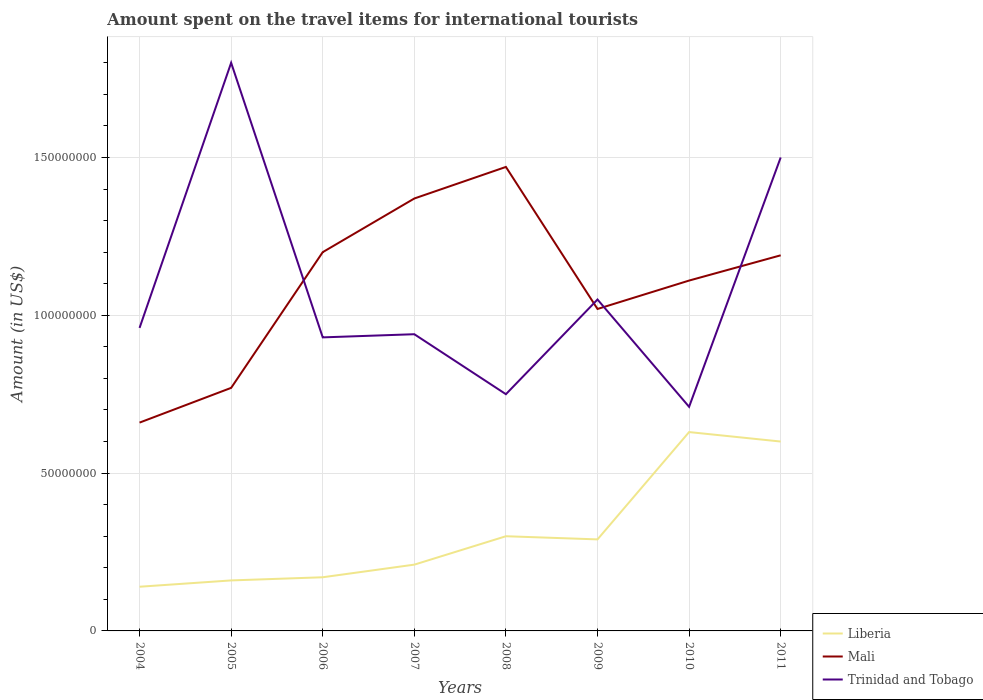How many different coloured lines are there?
Provide a short and direct response. 3. Across all years, what is the maximum amount spent on the travel items for international tourists in Mali?
Your answer should be compact. 6.60e+07. In which year was the amount spent on the travel items for international tourists in Mali maximum?
Offer a terse response. 2004. What is the total amount spent on the travel items for international tourists in Trinidad and Tobago in the graph?
Your answer should be very brief. 2.10e+07. What is the difference between the highest and the second highest amount spent on the travel items for international tourists in Liberia?
Your answer should be compact. 4.90e+07. What is the difference between the highest and the lowest amount spent on the travel items for international tourists in Trinidad and Tobago?
Your answer should be compact. 2. Is the amount spent on the travel items for international tourists in Trinidad and Tobago strictly greater than the amount spent on the travel items for international tourists in Mali over the years?
Keep it short and to the point. No. Are the values on the major ticks of Y-axis written in scientific E-notation?
Make the answer very short. No. Does the graph contain any zero values?
Ensure brevity in your answer.  No. Does the graph contain grids?
Your response must be concise. Yes. Where does the legend appear in the graph?
Offer a terse response. Bottom right. How many legend labels are there?
Your answer should be very brief. 3. What is the title of the graph?
Keep it short and to the point. Amount spent on the travel items for international tourists. Does "World" appear as one of the legend labels in the graph?
Offer a terse response. No. What is the Amount (in US$) of Liberia in 2004?
Your answer should be compact. 1.40e+07. What is the Amount (in US$) in Mali in 2004?
Provide a short and direct response. 6.60e+07. What is the Amount (in US$) in Trinidad and Tobago in 2004?
Keep it short and to the point. 9.60e+07. What is the Amount (in US$) in Liberia in 2005?
Give a very brief answer. 1.60e+07. What is the Amount (in US$) in Mali in 2005?
Your response must be concise. 7.70e+07. What is the Amount (in US$) of Trinidad and Tobago in 2005?
Make the answer very short. 1.80e+08. What is the Amount (in US$) of Liberia in 2006?
Your answer should be very brief. 1.70e+07. What is the Amount (in US$) in Mali in 2006?
Provide a short and direct response. 1.20e+08. What is the Amount (in US$) in Trinidad and Tobago in 2006?
Your answer should be very brief. 9.30e+07. What is the Amount (in US$) in Liberia in 2007?
Make the answer very short. 2.10e+07. What is the Amount (in US$) of Mali in 2007?
Give a very brief answer. 1.37e+08. What is the Amount (in US$) in Trinidad and Tobago in 2007?
Make the answer very short. 9.40e+07. What is the Amount (in US$) of Liberia in 2008?
Provide a short and direct response. 3.00e+07. What is the Amount (in US$) of Mali in 2008?
Offer a very short reply. 1.47e+08. What is the Amount (in US$) in Trinidad and Tobago in 2008?
Your answer should be compact. 7.50e+07. What is the Amount (in US$) of Liberia in 2009?
Offer a very short reply. 2.90e+07. What is the Amount (in US$) in Mali in 2009?
Give a very brief answer. 1.02e+08. What is the Amount (in US$) of Trinidad and Tobago in 2009?
Offer a terse response. 1.05e+08. What is the Amount (in US$) of Liberia in 2010?
Your response must be concise. 6.30e+07. What is the Amount (in US$) in Mali in 2010?
Your answer should be compact. 1.11e+08. What is the Amount (in US$) of Trinidad and Tobago in 2010?
Your response must be concise. 7.10e+07. What is the Amount (in US$) of Liberia in 2011?
Make the answer very short. 6.00e+07. What is the Amount (in US$) in Mali in 2011?
Offer a very short reply. 1.19e+08. What is the Amount (in US$) of Trinidad and Tobago in 2011?
Offer a terse response. 1.50e+08. Across all years, what is the maximum Amount (in US$) in Liberia?
Provide a short and direct response. 6.30e+07. Across all years, what is the maximum Amount (in US$) of Mali?
Ensure brevity in your answer.  1.47e+08. Across all years, what is the maximum Amount (in US$) in Trinidad and Tobago?
Ensure brevity in your answer.  1.80e+08. Across all years, what is the minimum Amount (in US$) of Liberia?
Offer a terse response. 1.40e+07. Across all years, what is the minimum Amount (in US$) of Mali?
Keep it short and to the point. 6.60e+07. Across all years, what is the minimum Amount (in US$) of Trinidad and Tobago?
Your answer should be compact. 7.10e+07. What is the total Amount (in US$) in Liberia in the graph?
Your answer should be compact. 2.50e+08. What is the total Amount (in US$) of Mali in the graph?
Your answer should be very brief. 8.79e+08. What is the total Amount (in US$) of Trinidad and Tobago in the graph?
Your answer should be compact. 8.64e+08. What is the difference between the Amount (in US$) in Liberia in 2004 and that in 2005?
Your answer should be compact. -2.00e+06. What is the difference between the Amount (in US$) of Mali in 2004 and that in 2005?
Give a very brief answer. -1.10e+07. What is the difference between the Amount (in US$) in Trinidad and Tobago in 2004 and that in 2005?
Provide a succinct answer. -8.40e+07. What is the difference between the Amount (in US$) in Mali in 2004 and that in 2006?
Your response must be concise. -5.40e+07. What is the difference between the Amount (in US$) in Liberia in 2004 and that in 2007?
Provide a short and direct response. -7.00e+06. What is the difference between the Amount (in US$) of Mali in 2004 and that in 2007?
Provide a short and direct response. -7.10e+07. What is the difference between the Amount (in US$) of Trinidad and Tobago in 2004 and that in 2007?
Keep it short and to the point. 2.00e+06. What is the difference between the Amount (in US$) in Liberia in 2004 and that in 2008?
Offer a very short reply. -1.60e+07. What is the difference between the Amount (in US$) of Mali in 2004 and that in 2008?
Give a very brief answer. -8.10e+07. What is the difference between the Amount (in US$) in Trinidad and Tobago in 2004 and that in 2008?
Your response must be concise. 2.10e+07. What is the difference between the Amount (in US$) of Liberia in 2004 and that in 2009?
Provide a short and direct response. -1.50e+07. What is the difference between the Amount (in US$) in Mali in 2004 and that in 2009?
Your answer should be compact. -3.60e+07. What is the difference between the Amount (in US$) in Trinidad and Tobago in 2004 and that in 2009?
Your response must be concise. -9.00e+06. What is the difference between the Amount (in US$) in Liberia in 2004 and that in 2010?
Give a very brief answer. -4.90e+07. What is the difference between the Amount (in US$) of Mali in 2004 and that in 2010?
Provide a short and direct response. -4.50e+07. What is the difference between the Amount (in US$) of Trinidad and Tobago in 2004 and that in 2010?
Make the answer very short. 2.50e+07. What is the difference between the Amount (in US$) of Liberia in 2004 and that in 2011?
Your answer should be very brief. -4.60e+07. What is the difference between the Amount (in US$) of Mali in 2004 and that in 2011?
Provide a short and direct response. -5.30e+07. What is the difference between the Amount (in US$) of Trinidad and Tobago in 2004 and that in 2011?
Provide a short and direct response. -5.40e+07. What is the difference between the Amount (in US$) of Mali in 2005 and that in 2006?
Ensure brevity in your answer.  -4.30e+07. What is the difference between the Amount (in US$) in Trinidad and Tobago in 2005 and that in 2006?
Provide a succinct answer. 8.70e+07. What is the difference between the Amount (in US$) in Liberia in 2005 and that in 2007?
Your answer should be compact. -5.00e+06. What is the difference between the Amount (in US$) in Mali in 2005 and that in 2007?
Give a very brief answer. -6.00e+07. What is the difference between the Amount (in US$) in Trinidad and Tobago in 2005 and that in 2007?
Give a very brief answer. 8.60e+07. What is the difference between the Amount (in US$) of Liberia in 2005 and that in 2008?
Your response must be concise. -1.40e+07. What is the difference between the Amount (in US$) in Mali in 2005 and that in 2008?
Keep it short and to the point. -7.00e+07. What is the difference between the Amount (in US$) in Trinidad and Tobago in 2005 and that in 2008?
Make the answer very short. 1.05e+08. What is the difference between the Amount (in US$) in Liberia in 2005 and that in 2009?
Provide a short and direct response. -1.30e+07. What is the difference between the Amount (in US$) in Mali in 2005 and that in 2009?
Provide a short and direct response. -2.50e+07. What is the difference between the Amount (in US$) of Trinidad and Tobago in 2005 and that in 2009?
Keep it short and to the point. 7.50e+07. What is the difference between the Amount (in US$) in Liberia in 2005 and that in 2010?
Your response must be concise. -4.70e+07. What is the difference between the Amount (in US$) of Mali in 2005 and that in 2010?
Provide a succinct answer. -3.40e+07. What is the difference between the Amount (in US$) of Trinidad and Tobago in 2005 and that in 2010?
Your answer should be compact. 1.09e+08. What is the difference between the Amount (in US$) of Liberia in 2005 and that in 2011?
Your response must be concise. -4.40e+07. What is the difference between the Amount (in US$) of Mali in 2005 and that in 2011?
Your answer should be compact. -4.20e+07. What is the difference between the Amount (in US$) of Trinidad and Tobago in 2005 and that in 2011?
Provide a succinct answer. 3.00e+07. What is the difference between the Amount (in US$) in Liberia in 2006 and that in 2007?
Keep it short and to the point. -4.00e+06. What is the difference between the Amount (in US$) of Mali in 2006 and that in 2007?
Offer a very short reply. -1.70e+07. What is the difference between the Amount (in US$) in Trinidad and Tobago in 2006 and that in 2007?
Offer a terse response. -1.00e+06. What is the difference between the Amount (in US$) in Liberia in 2006 and that in 2008?
Your answer should be compact. -1.30e+07. What is the difference between the Amount (in US$) of Mali in 2006 and that in 2008?
Make the answer very short. -2.70e+07. What is the difference between the Amount (in US$) in Trinidad and Tobago in 2006 and that in 2008?
Offer a terse response. 1.80e+07. What is the difference between the Amount (in US$) of Liberia in 2006 and that in 2009?
Offer a terse response. -1.20e+07. What is the difference between the Amount (in US$) in Mali in 2006 and that in 2009?
Provide a succinct answer. 1.80e+07. What is the difference between the Amount (in US$) of Trinidad and Tobago in 2006 and that in 2009?
Offer a terse response. -1.20e+07. What is the difference between the Amount (in US$) in Liberia in 2006 and that in 2010?
Ensure brevity in your answer.  -4.60e+07. What is the difference between the Amount (in US$) in Mali in 2006 and that in 2010?
Ensure brevity in your answer.  9.00e+06. What is the difference between the Amount (in US$) in Trinidad and Tobago in 2006 and that in 2010?
Keep it short and to the point. 2.20e+07. What is the difference between the Amount (in US$) in Liberia in 2006 and that in 2011?
Offer a terse response. -4.30e+07. What is the difference between the Amount (in US$) in Trinidad and Tobago in 2006 and that in 2011?
Offer a very short reply. -5.70e+07. What is the difference between the Amount (in US$) of Liberia in 2007 and that in 2008?
Provide a succinct answer. -9.00e+06. What is the difference between the Amount (in US$) of Mali in 2007 and that in 2008?
Your answer should be very brief. -1.00e+07. What is the difference between the Amount (in US$) of Trinidad and Tobago in 2007 and that in 2008?
Give a very brief answer. 1.90e+07. What is the difference between the Amount (in US$) of Liberia in 2007 and that in 2009?
Offer a very short reply. -8.00e+06. What is the difference between the Amount (in US$) in Mali in 2007 and that in 2009?
Your answer should be very brief. 3.50e+07. What is the difference between the Amount (in US$) of Trinidad and Tobago in 2007 and that in 2009?
Your response must be concise. -1.10e+07. What is the difference between the Amount (in US$) of Liberia in 2007 and that in 2010?
Make the answer very short. -4.20e+07. What is the difference between the Amount (in US$) of Mali in 2007 and that in 2010?
Offer a very short reply. 2.60e+07. What is the difference between the Amount (in US$) in Trinidad and Tobago in 2007 and that in 2010?
Offer a very short reply. 2.30e+07. What is the difference between the Amount (in US$) in Liberia in 2007 and that in 2011?
Ensure brevity in your answer.  -3.90e+07. What is the difference between the Amount (in US$) of Mali in 2007 and that in 2011?
Ensure brevity in your answer.  1.80e+07. What is the difference between the Amount (in US$) of Trinidad and Tobago in 2007 and that in 2011?
Provide a short and direct response. -5.60e+07. What is the difference between the Amount (in US$) in Mali in 2008 and that in 2009?
Your answer should be very brief. 4.50e+07. What is the difference between the Amount (in US$) in Trinidad and Tobago in 2008 and that in 2009?
Provide a succinct answer. -3.00e+07. What is the difference between the Amount (in US$) of Liberia in 2008 and that in 2010?
Keep it short and to the point. -3.30e+07. What is the difference between the Amount (in US$) of Mali in 2008 and that in 2010?
Keep it short and to the point. 3.60e+07. What is the difference between the Amount (in US$) of Liberia in 2008 and that in 2011?
Keep it short and to the point. -3.00e+07. What is the difference between the Amount (in US$) of Mali in 2008 and that in 2011?
Give a very brief answer. 2.80e+07. What is the difference between the Amount (in US$) in Trinidad and Tobago in 2008 and that in 2011?
Offer a terse response. -7.50e+07. What is the difference between the Amount (in US$) in Liberia in 2009 and that in 2010?
Keep it short and to the point. -3.40e+07. What is the difference between the Amount (in US$) of Mali in 2009 and that in 2010?
Offer a very short reply. -9.00e+06. What is the difference between the Amount (in US$) in Trinidad and Tobago in 2009 and that in 2010?
Provide a succinct answer. 3.40e+07. What is the difference between the Amount (in US$) of Liberia in 2009 and that in 2011?
Your answer should be very brief. -3.10e+07. What is the difference between the Amount (in US$) of Mali in 2009 and that in 2011?
Provide a short and direct response. -1.70e+07. What is the difference between the Amount (in US$) in Trinidad and Tobago in 2009 and that in 2011?
Offer a very short reply. -4.50e+07. What is the difference between the Amount (in US$) of Liberia in 2010 and that in 2011?
Provide a short and direct response. 3.00e+06. What is the difference between the Amount (in US$) in Mali in 2010 and that in 2011?
Your answer should be compact. -8.00e+06. What is the difference between the Amount (in US$) in Trinidad and Tobago in 2010 and that in 2011?
Offer a very short reply. -7.90e+07. What is the difference between the Amount (in US$) of Liberia in 2004 and the Amount (in US$) of Mali in 2005?
Make the answer very short. -6.30e+07. What is the difference between the Amount (in US$) of Liberia in 2004 and the Amount (in US$) of Trinidad and Tobago in 2005?
Offer a very short reply. -1.66e+08. What is the difference between the Amount (in US$) in Mali in 2004 and the Amount (in US$) in Trinidad and Tobago in 2005?
Ensure brevity in your answer.  -1.14e+08. What is the difference between the Amount (in US$) in Liberia in 2004 and the Amount (in US$) in Mali in 2006?
Ensure brevity in your answer.  -1.06e+08. What is the difference between the Amount (in US$) of Liberia in 2004 and the Amount (in US$) of Trinidad and Tobago in 2006?
Your answer should be compact. -7.90e+07. What is the difference between the Amount (in US$) of Mali in 2004 and the Amount (in US$) of Trinidad and Tobago in 2006?
Your response must be concise. -2.70e+07. What is the difference between the Amount (in US$) of Liberia in 2004 and the Amount (in US$) of Mali in 2007?
Your answer should be very brief. -1.23e+08. What is the difference between the Amount (in US$) in Liberia in 2004 and the Amount (in US$) in Trinidad and Tobago in 2007?
Give a very brief answer. -8.00e+07. What is the difference between the Amount (in US$) of Mali in 2004 and the Amount (in US$) of Trinidad and Tobago in 2007?
Ensure brevity in your answer.  -2.80e+07. What is the difference between the Amount (in US$) in Liberia in 2004 and the Amount (in US$) in Mali in 2008?
Keep it short and to the point. -1.33e+08. What is the difference between the Amount (in US$) of Liberia in 2004 and the Amount (in US$) of Trinidad and Tobago in 2008?
Make the answer very short. -6.10e+07. What is the difference between the Amount (in US$) of Mali in 2004 and the Amount (in US$) of Trinidad and Tobago in 2008?
Give a very brief answer. -9.00e+06. What is the difference between the Amount (in US$) in Liberia in 2004 and the Amount (in US$) in Mali in 2009?
Your response must be concise. -8.80e+07. What is the difference between the Amount (in US$) in Liberia in 2004 and the Amount (in US$) in Trinidad and Tobago in 2009?
Provide a succinct answer. -9.10e+07. What is the difference between the Amount (in US$) in Mali in 2004 and the Amount (in US$) in Trinidad and Tobago in 2009?
Your answer should be compact. -3.90e+07. What is the difference between the Amount (in US$) in Liberia in 2004 and the Amount (in US$) in Mali in 2010?
Your answer should be very brief. -9.70e+07. What is the difference between the Amount (in US$) in Liberia in 2004 and the Amount (in US$) in Trinidad and Tobago in 2010?
Provide a succinct answer. -5.70e+07. What is the difference between the Amount (in US$) in Mali in 2004 and the Amount (in US$) in Trinidad and Tobago in 2010?
Offer a terse response. -5.00e+06. What is the difference between the Amount (in US$) of Liberia in 2004 and the Amount (in US$) of Mali in 2011?
Provide a short and direct response. -1.05e+08. What is the difference between the Amount (in US$) of Liberia in 2004 and the Amount (in US$) of Trinidad and Tobago in 2011?
Give a very brief answer. -1.36e+08. What is the difference between the Amount (in US$) of Mali in 2004 and the Amount (in US$) of Trinidad and Tobago in 2011?
Your response must be concise. -8.40e+07. What is the difference between the Amount (in US$) of Liberia in 2005 and the Amount (in US$) of Mali in 2006?
Ensure brevity in your answer.  -1.04e+08. What is the difference between the Amount (in US$) of Liberia in 2005 and the Amount (in US$) of Trinidad and Tobago in 2006?
Offer a very short reply. -7.70e+07. What is the difference between the Amount (in US$) of Mali in 2005 and the Amount (in US$) of Trinidad and Tobago in 2006?
Ensure brevity in your answer.  -1.60e+07. What is the difference between the Amount (in US$) in Liberia in 2005 and the Amount (in US$) in Mali in 2007?
Your answer should be very brief. -1.21e+08. What is the difference between the Amount (in US$) in Liberia in 2005 and the Amount (in US$) in Trinidad and Tobago in 2007?
Offer a very short reply. -7.80e+07. What is the difference between the Amount (in US$) of Mali in 2005 and the Amount (in US$) of Trinidad and Tobago in 2007?
Offer a terse response. -1.70e+07. What is the difference between the Amount (in US$) of Liberia in 2005 and the Amount (in US$) of Mali in 2008?
Offer a very short reply. -1.31e+08. What is the difference between the Amount (in US$) of Liberia in 2005 and the Amount (in US$) of Trinidad and Tobago in 2008?
Provide a succinct answer. -5.90e+07. What is the difference between the Amount (in US$) in Liberia in 2005 and the Amount (in US$) in Mali in 2009?
Offer a terse response. -8.60e+07. What is the difference between the Amount (in US$) in Liberia in 2005 and the Amount (in US$) in Trinidad and Tobago in 2009?
Keep it short and to the point. -8.90e+07. What is the difference between the Amount (in US$) in Mali in 2005 and the Amount (in US$) in Trinidad and Tobago in 2009?
Provide a short and direct response. -2.80e+07. What is the difference between the Amount (in US$) of Liberia in 2005 and the Amount (in US$) of Mali in 2010?
Your answer should be compact. -9.50e+07. What is the difference between the Amount (in US$) of Liberia in 2005 and the Amount (in US$) of Trinidad and Tobago in 2010?
Provide a succinct answer. -5.50e+07. What is the difference between the Amount (in US$) of Liberia in 2005 and the Amount (in US$) of Mali in 2011?
Make the answer very short. -1.03e+08. What is the difference between the Amount (in US$) of Liberia in 2005 and the Amount (in US$) of Trinidad and Tobago in 2011?
Offer a very short reply. -1.34e+08. What is the difference between the Amount (in US$) of Mali in 2005 and the Amount (in US$) of Trinidad and Tobago in 2011?
Provide a succinct answer. -7.30e+07. What is the difference between the Amount (in US$) of Liberia in 2006 and the Amount (in US$) of Mali in 2007?
Your answer should be compact. -1.20e+08. What is the difference between the Amount (in US$) of Liberia in 2006 and the Amount (in US$) of Trinidad and Tobago in 2007?
Provide a succinct answer. -7.70e+07. What is the difference between the Amount (in US$) of Mali in 2006 and the Amount (in US$) of Trinidad and Tobago in 2007?
Keep it short and to the point. 2.60e+07. What is the difference between the Amount (in US$) in Liberia in 2006 and the Amount (in US$) in Mali in 2008?
Your response must be concise. -1.30e+08. What is the difference between the Amount (in US$) in Liberia in 2006 and the Amount (in US$) in Trinidad and Tobago in 2008?
Provide a succinct answer. -5.80e+07. What is the difference between the Amount (in US$) of Mali in 2006 and the Amount (in US$) of Trinidad and Tobago in 2008?
Your answer should be compact. 4.50e+07. What is the difference between the Amount (in US$) in Liberia in 2006 and the Amount (in US$) in Mali in 2009?
Ensure brevity in your answer.  -8.50e+07. What is the difference between the Amount (in US$) of Liberia in 2006 and the Amount (in US$) of Trinidad and Tobago in 2009?
Your answer should be compact. -8.80e+07. What is the difference between the Amount (in US$) in Mali in 2006 and the Amount (in US$) in Trinidad and Tobago in 2009?
Your answer should be compact. 1.50e+07. What is the difference between the Amount (in US$) of Liberia in 2006 and the Amount (in US$) of Mali in 2010?
Provide a short and direct response. -9.40e+07. What is the difference between the Amount (in US$) of Liberia in 2006 and the Amount (in US$) of Trinidad and Tobago in 2010?
Give a very brief answer. -5.40e+07. What is the difference between the Amount (in US$) in Mali in 2006 and the Amount (in US$) in Trinidad and Tobago in 2010?
Ensure brevity in your answer.  4.90e+07. What is the difference between the Amount (in US$) of Liberia in 2006 and the Amount (in US$) of Mali in 2011?
Offer a very short reply. -1.02e+08. What is the difference between the Amount (in US$) in Liberia in 2006 and the Amount (in US$) in Trinidad and Tobago in 2011?
Ensure brevity in your answer.  -1.33e+08. What is the difference between the Amount (in US$) in Mali in 2006 and the Amount (in US$) in Trinidad and Tobago in 2011?
Make the answer very short. -3.00e+07. What is the difference between the Amount (in US$) in Liberia in 2007 and the Amount (in US$) in Mali in 2008?
Give a very brief answer. -1.26e+08. What is the difference between the Amount (in US$) of Liberia in 2007 and the Amount (in US$) of Trinidad and Tobago in 2008?
Your answer should be compact. -5.40e+07. What is the difference between the Amount (in US$) in Mali in 2007 and the Amount (in US$) in Trinidad and Tobago in 2008?
Provide a succinct answer. 6.20e+07. What is the difference between the Amount (in US$) in Liberia in 2007 and the Amount (in US$) in Mali in 2009?
Your answer should be compact. -8.10e+07. What is the difference between the Amount (in US$) of Liberia in 2007 and the Amount (in US$) of Trinidad and Tobago in 2009?
Keep it short and to the point. -8.40e+07. What is the difference between the Amount (in US$) of Mali in 2007 and the Amount (in US$) of Trinidad and Tobago in 2009?
Offer a terse response. 3.20e+07. What is the difference between the Amount (in US$) of Liberia in 2007 and the Amount (in US$) of Mali in 2010?
Give a very brief answer. -9.00e+07. What is the difference between the Amount (in US$) of Liberia in 2007 and the Amount (in US$) of Trinidad and Tobago in 2010?
Keep it short and to the point. -5.00e+07. What is the difference between the Amount (in US$) of Mali in 2007 and the Amount (in US$) of Trinidad and Tobago in 2010?
Keep it short and to the point. 6.60e+07. What is the difference between the Amount (in US$) in Liberia in 2007 and the Amount (in US$) in Mali in 2011?
Give a very brief answer. -9.80e+07. What is the difference between the Amount (in US$) in Liberia in 2007 and the Amount (in US$) in Trinidad and Tobago in 2011?
Keep it short and to the point. -1.29e+08. What is the difference between the Amount (in US$) in Mali in 2007 and the Amount (in US$) in Trinidad and Tobago in 2011?
Ensure brevity in your answer.  -1.30e+07. What is the difference between the Amount (in US$) in Liberia in 2008 and the Amount (in US$) in Mali in 2009?
Offer a very short reply. -7.20e+07. What is the difference between the Amount (in US$) of Liberia in 2008 and the Amount (in US$) of Trinidad and Tobago in 2009?
Your response must be concise. -7.50e+07. What is the difference between the Amount (in US$) of Mali in 2008 and the Amount (in US$) of Trinidad and Tobago in 2009?
Keep it short and to the point. 4.20e+07. What is the difference between the Amount (in US$) in Liberia in 2008 and the Amount (in US$) in Mali in 2010?
Keep it short and to the point. -8.10e+07. What is the difference between the Amount (in US$) in Liberia in 2008 and the Amount (in US$) in Trinidad and Tobago in 2010?
Your response must be concise. -4.10e+07. What is the difference between the Amount (in US$) of Mali in 2008 and the Amount (in US$) of Trinidad and Tobago in 2010?
Provide a succinct answer. 7.60e+07. What is the difference between the Amount (in US$) of Liberia in 2008 and the Amount (in US$) of Mali in 2011?
Offer a terse response. -8.90e+07. What is the difference between the Amount (in US$) of Liberia in 2008 and the Amount (in US$) of Trinidad and Tobago in 2011?
Give a very brief answer. -1.20e+08. What is the difference between the Amount (in US$) in Mali in 2008 and the Amount (in US$) in Trinidad and Tobago in 2011?
Make the answer very short. -3.00e+06. What is the difference between the Amount (in US$) in Liberia in 2009 and the Amount (in US$) in Mali in 2010?
Ensure brevity in your answer.  -8.20e+07. What is the difference between the Amount (in US$) of Liberia in 2009 and the Amount (in US$) of Trinidad and Tobago in 2010?
Provide a short and direct response. -4.20e+07. What is the difference between the Amount (in US$) of Mali in 2009 and the Amount (in US$) of Trinidad and Tobago in 2010?
Your response must be concise. 3.10e+07. What is the difference between the Amount (in US$) in Liberia in 2009 and the Amount (in US$) in Mali in 2011?
Ensure brevity in your answer.  -9.00e+07. What is the difference between the Amount (in US$) of Liberia in 2009 and the Amount (in US$) of Trinidad and Tobago in 2011?
Ensure brevity in your answer.  -1.21e+08. What is the difference between the Amount (in US$) in Mali in 2009 and the Amount (in US$) in Trinidad and Tobago in 2011?
Ensure brevity in your answer.  -4.80e+07. What is the difference between the Amount (in US$) of Liberia in 2010 and the Amount (in US$) of Mali in 2011?
Keep it short and to the point. -5.60e+07. What is the difference between the Amount (in US$) in Liberia in 2010 and the Amount (in US$) in Trinidad and Tobago in 2011?
Make the answer very short. -8.70e+07. What is the difference between the Amount (in US$) in Mali in 2010 and the Amount (in US$) in Trinidad and Tobago in 2011?
Your response must be concise. -3.90e+07. What is the average Amount (in US$) in Liberia per year?
Your answer should be very brief. 3.12e+07. What is the average Amount (in US$) of Mali per year?
Offer a very short reply. 1.10e+08. What is the average Amount (in US$) in Trinidad and Tobago per year?
Keep it short and to the point. 1.08e+08. In the year 2004, what is the difference between the Amount (in US$) of Liberia and Amount (in US$) of Mali?
Make the answer very short. -5.20e+07. In the year 2004, what is the difference between the Amount (in US$) of Liberia and Amount (in US$) of Trinidad and Tobago?
Your answer should be compact. -8.20e+07. In the year 2004, what is the difference between the Amount (in US$) in Mali and Amount (in US$) in Trinidad and Tobago?
Ensure brevity in your answer.  -3.00e+07. In the year 2005, what is the difference between the Amount (in US$) of Liberia and Amount (in US$) of Mali?
Ensure brevity in your answer.  -6.10e+07. In the year 2005, what is the difference between the Amount (in US$) of Liberia and Amount (in US$) of Trinidad and Tobago?
Ensure brevity in your answer.  -1.64e+08. In the year 2005, what is the difference between the Amount (in US$) in Mali and Amount (in US$) in Trinidad and Tobago?
Your response must be concise. -1.03e+08. In the year 2006, what is the difference between the Amount (in US$) of Liberia and Amount (in US$) of Mali?
Keep it short and to the point. -1.03e+08. In the year 2006, what is the difference between the Amount (in US$) in Liberia and Amount (in US$) in Trinidad and Tobago?
Offer a terse response. -7.60e+07. In the year 2006, what is the difference between the Amount (in US$) in Mali and Amount (in US$) in Trinidad and Tobago?
Your answer should be very brief. 2.70e+07. In the year 2007, what is the difference between the Amount (in US$) of Liberia and Amount (in US$) of Mali?
Provide a short and direct response. -1.16e+08. In the year 2007, what is the difference between the Amount (in US$) of Liberia and Amount (in US$) of Trinidad and Tobago?
Your answer should be very brief. -7.30e+07. In the year 2007, what is the difference between the Amount (in US$) in Mali and Amount (in US$) in Trinidad and Tobago?
Provide a short and direct response. 4.30e+07. In the year 2008, what is the difference between the Amount (in US$) in Liberia and Amount (in US$) in Mali?
Keep it short and to the point. -1.17e+08. In the year 2008, what is the difference between the Amount (in US$) in Liberia and Amount (in US$) in Trinidad and Tobago?
Offer a very short reply. -4.50e+07. In the year 2008, what is the difference between the Amount (in US$) in Mali and Amount (in US$) in Trinidad and Tobago?
Offer a terse response. 7.20e+07. In the year 2009, what is the difference between the Amount (in US$) of Liberia and Amount (in US$) of Mali?
Provide a short and direct response. -7.30e+07. In the year 2009, what is the difference between the Amount (in US$) of Liberia and Amount (in US$) of Trinidad and Tobago?
Provide a short and direct response. -7.60e+07. In the year 2010, what is the difference between the Amount (in US$) of Liberia and Amount (in US$) of Mali?
Give a very brief answer. -4.80e+07. In the year 2010, what is the difference between the Amount (in US$) of Liberia and Amount (in US$) of Trinidad and Tobago?
Make the answer very short. -8.00e+06. In the year 2010, what is the difference between the Amount (in US$) of Mali and Amount (in US$) of Trinidad and Tobago?
Offer a terse response. 4.00e+07. In the year 2011, what is the difference between the Amount (in US$) of Liberia and Amount (in US$) of Mali?
Give a very brief answer. -5.90e+07. In the year 2011, what is the difference between the Amount (in US$) of Liberia and Amount (in US$) of Trinidad and Tobago?
Your answer should be very brief. -9.00e+07. In the year 2011, what is the difference between the Amount (in US$) in Mali and Amount (in US$) in Trinidad and Tobago?
Offer a very short reply. -3.10e+07. What is the ratio of the Amount (in US$) in Liberia in 2004 to that in 2005?
Your answer should be compact. 0.88. What is the ratio of the Amount (in US$) of Trinidad and Tobago in 2004 to that in 2005?
Ensure brevity in your answer.  0.53. What is the ratio of the Amount (in US$) of Liberia in 2004 to that in 2006?
Make the answer very short. 0.82. What is the ratio of the Amount (in US$) of Mali in 2004 to that in 2006?
Make the answer very short. 0.55. What is the ratio of the Amount (in US$) in Trinidad and Tobago in 2004 to that in 2006?
Your answer should be very brief. 1.03. What is the ratio of the Amount (in US$) in Mali in 2004 to that in 2007?
Ensure brevity in your answer.  0.48. What is the ratio of the Amount (in US$) of Trinidad and Tobago in 2004 to that in 2007?
Make the answer very short. 1.02. What is the ratio of the Amount (in US$) of Liberia in 2004 to that in 2008?
Ensure brevity in your answer.  0.47. What is the ratio of the Amount (in US$) in Mali in 2004 to that in 2008?
Ensure brevity in your answer.  0.45. What is the ratio of the Amount (in US$) in Trinidad and Tobago in 2004 to that in 2008?
Provide a short and direct response. 1.28. What is the ratio of the Amount (in US$) of Liberia in 2004 to that in 2009?
Provide a succinct answer. 0.48. What is the ratio of the Amount (in US$) in Mali in 2004 to that in 2009?
Keep it short and to the point. 0.65. What is the ratio of the Amount (in US$) in Trinidad and Tobago in 2004 to that in 2009?
Offer a very short reply. 0.91. What is the ratio of the Amount (in US$) of Liberia in 2004 to that in 2010?
Ensure brevity in your answer.  0.22. What is the ratio of the Amount (in US$) in Mali in 2004 to that in 2010?
Your response must be concise. 0.59. What is the ratio of the Amount (in US$) in Trinidad and Tobago in 2004 to that in 2010?
Offer a terse response. 1.35. What is the ratio of the Amount (in US$) of Liberia in 2004 to that in 2011?
Provide a short and direct response. 0.23. What is the ratio of the Amount (in US$) of Mali in 2004 to that in 2011?
Ensure brevity in your answer.  0.55. What is the ratio of the Amount (in US$) of Trinidad and Tobago in 2004 to that in 2011?
Your answer should be very brief. 0.64. What is the ratio of the Amount (in US$) of Liberia in 2005 to that in 2006?
Offer a terse response. 0.94. What is the ratio of the Amount (in US$) in Mali in 2005 to that in 2006?
Offer a terse response. 0.64. What is the ratio of the Amount (in US$) of Trinidad and Tobago in 2005 to that in 2006?
Ensure brevity in your answer.  1.94. What is the ratio of the Amount (in US$) in Liberia in 2005 to that in 2007?
Offer a terse response. 0.76. What is the ratio of the Amount (in US$) of Mali in 2005 to that in 2007?
Provide a succinct answer. 0.56. What is the ratio of the Amount (in US$) of Trinidad and Tobago in 2005 to that in 2007?
Keep it short and to the point. 1.91. What is the ratio of the Amount (in US$) of Liberia in 2005 to that in 2008?
Provide a succinct answer. 0.53. What is the ratio of the Amount (in US$) in Mali in 2005 to that in 2008?
Your response must be concise. 0.52. What is the ratio of the Amount (in US$) of Liberia in 2005 to that in 2009?
Provide a short and direct response. 0.55. What is the ratio of the Amount (in US$) of Mali in 2005 to that in 2009?
Your answer should be compact. 0.75. What is the ratio of the Amount (in US$) of Trinidad and Tobago in 2005 to that in 2009?
Make the answer very short. 1.71. What is the ratio of the Amount (in US$) in Liberia in 2005 to that in 2010?
Offer a terse response. 0.25. What is the ratio of the Amount (in US$) in Mali in 2005 to that in 2010?
Offer a terse response. 0.69. What is the ratio of the Amount (in US$) in Trinidad and Tobago in 2005 to that in 2010?
Make the answer very short. 2.54. What is the ratio of the Amount (in US$) of Liberia in 2005 to that in 2011?
Give a very brief answer. 0.27. What is the ratio of the Amount (in US$) of Mali in 2005 to that in 2011?
Give a very brief answer. 0.65. What is the ratio of the Amount (in US$) of Trinidad and Tobago in 2005 to that in 2011?
Your answer should be very brief. 1.2. What is the ratio of the Amount (in US$) in Liberia in 2006 to that in 2007?
Your response must be concise. 0.81. What is the ratio of the Amount (in US$) of Mali in 2006 to that in 2007?
Give a very brief answer. 0.88. What is the ratio of the Amount (in US$) of Liberia in 2006 to that in 2008?
Your response must be concise. 0.57. What is the ratio of the Amount (in US$) in Mali in 2006 to that in 2008?
Provide a succinct answer. 0.82. What is the ratio of the Amount (in US$) in Trinidad and Tobago in 2006 to that in 2008?
Give a very brief answer. 1.24. What is the ratio of the Amount (in US$) of Liberia in 2006 to that in 2009?
Ensure brevity in your answer.  0.59. What is the ratio of the Amount (in US$) in Mali in 2006 to that in 2009?
Your response must be concise. 1.18. What is the ratio of the Amount (in US$) in Trinidad and Tobago in 2006 to that in 2009?
Offer a very short reply. 0.89. What is the ratio of the Amount (in US$) of Liberia in 2006 to that in 2010?
Your response must be concise. 0.27. What is the ratio of the Amount (in US$) in Mali in 2006 to that in 2010?
Give a very brief answer. 1.08. What is the ratio of the Amount (in US$) of Trinidad and Tobago in 2006 to that in 2010?
Provide a succinct answer. 1.31. What is the ratio of the Amount (in US$) in Liberia in 2006 to that in 2011?
Give a very brief answer. 0.28. What is the ratio of the Amount (in US$) of Mali in 2006 to that in 2011?
Your response must be concise. 1.01. What is the ratio of the Amount (in US$) in Trinidad and Tobago in 2006 to that in 2011?
Offer a terse response. 0.62. What is the ratio of the Amount (in US$) of Mali in 2007 to that in 2008?
Ensure brevity in your answer.  0.93. What is the ratio of the Amount (in US$) of Trinidad and Tobago in 2007 to that in 2008?
Keep it short and to the point. 1.25. What is the ratio of the Amount (in US$) in Liberia in 2007 to that in 2009?
Provide a short and direct response. 0.72. What is the ratio of the Amount (in US$) in Mali in 2007 to that in 2009?
Provide a succinct answer. 1.34. What is the ratio of the Amount (in US$) of Trinidad and Tobago in 2007 to that in 2009?
Your response must be concise. 0.9. What is the ratio of the Amount (in US$) of Mali in 2007 to that in 2010?
Make the answer very short. 1.23. What is the ratio of the Amount (in US$) in Trinidad and Tobago in 2007 to that in 2010?
Make the answer very short. 1.32. What is the ratio of the Amount (in US$) in Mali in 2007 to that in 2011?
Provide a short and direct response. 1.15. What is the ratio of the Amount (in US$) in Trinidad and Tobago in 2007 to that in 2011?
Your answer should be very brief. 0.63. What is the ratio of the Amount (in US$) of Liberia in 2008 to that in 2009?
Your answer should be very brief. 1.03. What is the ratio of the Amount (in US$) of Mali in 2008 to that in 2009?
Offer a terse response. 1.44. What is the ratio of the Amount (in US$) in Liberia in 2008 to that in 2010?
Give a very brief answer. 0.48. What is the ratio of the Amount (in US$) of Mali in 2008 to that in 2010?
Your response must be concise. 1.32. What is the ratio of the Amount (in US$) of Trinidad and Tobago in 2008 to that in 2010?
Your answer should be compact. 1.06. What is the ratio of the Amount (in US$) of Liberia in 2008 to that in 2011?
Offer a very short reply. 0.5. What is the ratio of the Amount (in US$) in Mali in 2008 to that in 2011?
Provide a succinct answer. 1.24. What is the ratio of the Amount (in US$) in Trinidad and Tobago in 2008 to that in 2011?
Make the answer very short. 0.5. What is the ratio of the Amount (in US$) of Liberia in 2009 to that in 2010?
Keep it short and to the point. 0.46. What is the ratio of the Amount (in US$) in Mali in 2009 to that in 2010?
Your answer should be compact. 0.92. What is the ratio of the Amount (in US$) in Trinidad and Tobago in 2009 to that in 2010?
Offer a terse response. 1.48. What is the ratio of the Amount (in US$) of Liberia in 2009 to that in 2011?
Keep it short and to the point. 0.48. What is the ratio of the Amount (in US$) in Trinidad and Tobago in 2009 to that in 2011?
Make the answer very short. 0.7. What is the ratio of the Amount (in US$) in Mali in 2010 to that in 2011?
Your answer should be compact. 0.93. What is the ratio of the Amount (in US$) of Trinidad and Tobago in 2010 to that in 2011?
Offer a very short reply. 0.47. What is the difference between the highest and the second highest Amount (in US$) of Mali?
Your response must be concise. 1.00e+07. What is the difference between the highest and the second highest Amount (in US$) of Trinidad and Tobago?
Your answer should be very brief. 3.00e+07. What is the difference between the highest and the lowest Amount (in US$) in Liberia?
Your response must be concise. 4.90e+07. What is the difference between the highest and the lowest Amount (in US$) of Mali?
Your response must be concise. 8.10e+07. What is the difference between the highest and the lowest Amount (in US$) of Trinidad and Tobago?
Your answer should be very brief. 1.09e+08. 